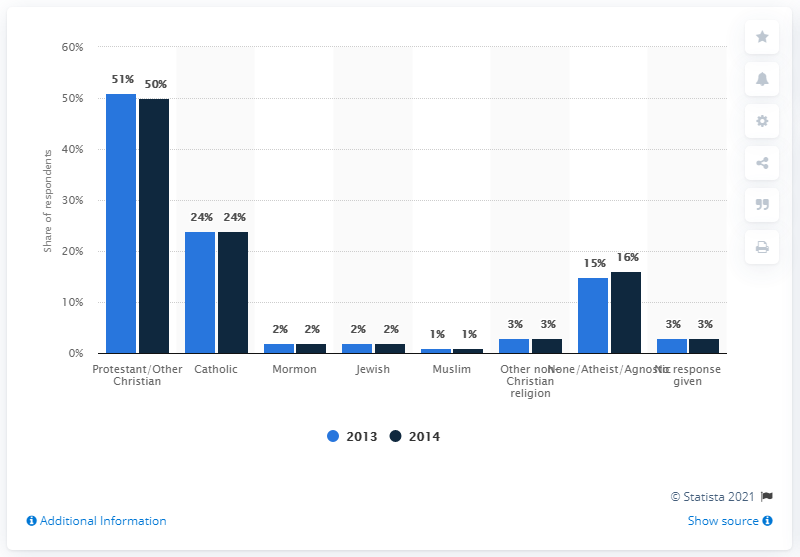Identify some key points in this picture. The least popular religion in the chart is Islam. The chart indicates that one religion has decreased in followers. 